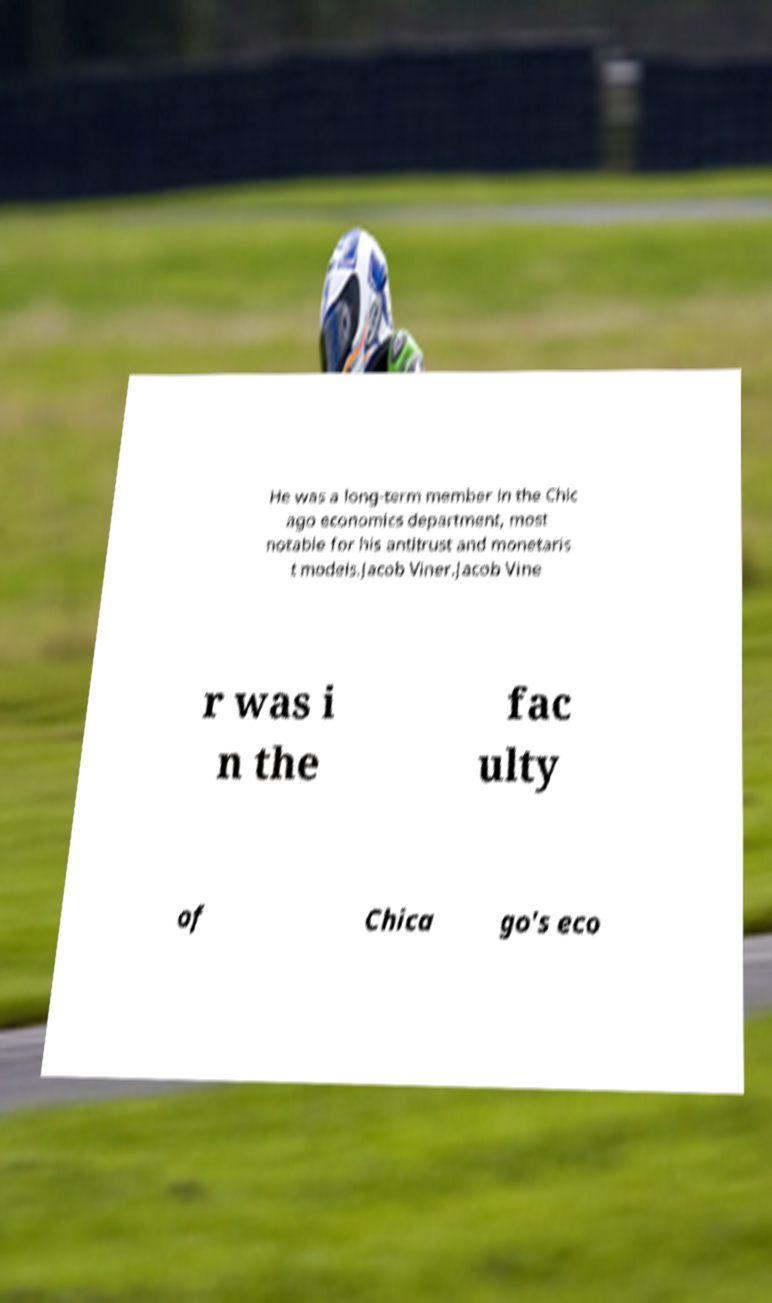Please read and relay the text visible in this image. What does it say? He was a long-term member in the Chic ago economics department, most notable for his antitrust and monetaris t models.Jacob Viner.Jacob Vine r was i n the fac ulty of Chica go's eco 